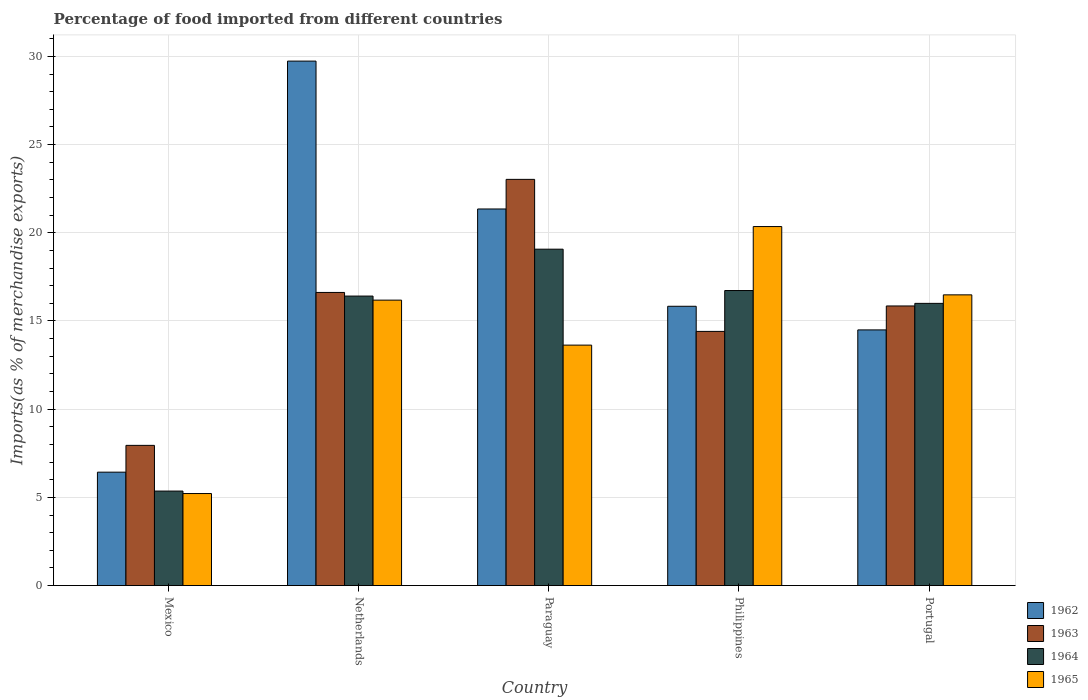Are the number of bars per tick equal to the number of legend labels?
Your answer should be very brief. Yes. Are the number of bars on each tick of the X-axis equal?
Your answer should be very brief. Yes. How many bars are there on the 4th tick from the left?
Your answer should be very brief. 4. What is the label of the 2nd group of bars from the left?
Provide a short and direct response. Netherlands. In how many cases, is the number of bars for a given country not equal to the number of legend labels?
Your answer should be very brief. 0. What is the percentage of imports to different countries in 1964 in Portugal?
Make the answer very short. 16. Across all countries, what is the maximum percentage of imports to different countries in 1965?
Ensure brevity in your answer.  20.35. Across all countries, what is the minimum percentage of imports to different countries in 1962?
Your answer should be compact. 6.43. In which country was the percentage of imports to different countries in 1965 maximum?
Offer a very short reply. Philippines. In which country was the percentage of imports to different countries in 1962 minimum?
Your answer should be compact. Mexico. What is the total percentage of imports to different countries in 1963 in the graph?
Offer a very short reply. 77.86. What is the difference between the percentage of imports to different countries in 1964 in Netherlands and that in Paraguay?
Your response must be concise. -2.66. What is the difference between the percentage of imports to different countries in 1962 in Paraguay and the percentage of imports to different countries in 1965 in Philippines?
Give a very brief answer. 1. What is the average percentage of imports to different countries in 1964 per country?
Your response must be concise. 14.71. What is the difference between the percentage of imports to different countries of/in 1965 and percentage of imports to different countries of/in 1963 in Philippines?
Give a very brief answer. 5.94. In how many countries, is the percentage of imports to different countries in 1963 greater than 10 %?
Provide a short and direct response. 4. What is the ratio of the percentage of imports to different countries in 1962 in Paraguay to that in Portugal?
Give a very brief answer. 1.47. What is the difference between the highest and the second highest percentage of imports to different countries in 1965?
Make the answer very short. 0.3. What is the difference between the highest and the lowest percentage of imports to different countries in 1964?
Give a very brief answer. 13.71. In how many countries, is the percentage of imports to different countries in 1965 greater than the average percentage of imports to different countries in 1965 taken over all countries?
Make the answer very short. 3. Is the sum of the percentage of imports to different countries in 1965 in Netherlands and Portugal greater than the maximum percentage of imports to different countries in 1964 across all countries?
Provide a succinct answer. Yes. What does the 2nd bar from the left in Netherlands represents?
Provide a short and direct response. 1963. How many bars are there?
Keep it short and to the point. 20. What is the difference between two consecutive major ticks on the Y-axis?
Ensure brevity in your answer.  5. How are the legend labels stacked?
Provide a succinct answer. Vertical. What is the title of the graph?
Provide a succinct answer. Percentage of food imported from different countries. Does "1983" appear as one of the legend labels in the graph?
Provide a short and direct response. No. What is the label or title of the X-axis?
Your answer should be very brief. Country. What is the label or title of the Y-axis?
Keep it short and to the point. Imports(as % of merchandise exports). What is the Imports(as % of merchandise exports) in 1962 in Mexico?
Provide a succinct answer. 6.43. What is the Imports(as % of merchandise exports) of 1963 in Mexico?
Your response must be concise. 7.95. What is the Imports(as % of merchandise exports) of 1964 in Mexico?
Make the answer very short. 5.36. What is the Imports(as % of merchandise exports) of 1965 in Mexico?
Provide a short and direct response. 5.22. What is the Imports(as % of merchandise exports) in 1962 in Netherlands?
Keep it short and to the point. 29.73. What is the Imports(as % of merchandise exports) in 1963 in Netherlands?
Make the answer very short. 16.62. What is the Imports(as % of merchandise exports) in 1964 in Netherlands?
Provide a short and direct response. 16.41. What is the Imports(as % of merchandise exports) of 1965 in Netherlands?
Offer a very short reply. 16.18. What is the Imports(as % of merchandise exports) of 1962 in Paraguay?
Make the answer very short. 21.35. What is the Imports(as % of merchandise exports) of 1963 in Paraguay?
Give a very brief answer. 23.03. What is the Imports(as % of merchandise exports) of 1964 in Paraguay?
Your response must be concise. 19.07. What is the Imports(as % of merchandise exports) of 1965 in Paraguay?
Ensure brevity in your answer.  13.63. What is the Imports(as % of merchandise exports) in 1962 in Philippines?
Provide a short and direct response. 15.83. What is the Imports(as % of merchandise exports) of 1963 in Philippines?
Your answer should be compact. 14.41. What is the Imports(as % of merchandise exports) in 1964 in Philippines?
Provide a short and direct response. 16.73. What is the Imports(as % of merchandise exports) in 1965 in Philippines?
Keep it short and to the point. 20.35. What is the Imports(as % of merchandise exports) in 1962 in Portugal?
Ensure brevity in your answer.  14.49. What is the Imports(as % of merchandise exports) of 1963 in Portugal?
Offer a very short reply. 15.85. What is the Imports(as % of merchandise exports) of 1964 in Portugal?
Offer a terse response. 16. What is the Imports(as % of merchandise exports) of 1965 in Portugal?
Your answer should be very brief. 16.48. Across all countries, what is the maximum Imports(as % of merchandise exports) of 1962?
Your answer should be compact. 29.73. Across all countries, what is the maximum Imports(as % of merchandise exports) in 1963?
Give a very brief answer. 23.03. Across all countries, what is the maximum Imports(as % of merchandise exports) of 1964?
Your answer should be compact. 19.07. Across all countries, what is the maximum Imports(as % of merchandise exports) in 1965?
Your answer should be very brief. 20.35. Across all countries, what is the minimum Imports(as % of merchandise exports) in 1962?
Your answer should be compact. 6.43. Across all countries, what is the minimum Imports(as % of merchandise exports) of 1963?
Your response must be concise. 7.95. Across all countries, what is the minimum Imports(as % of merchandise exports) of 1964?
Offer a terse response. 5.36. Across all countries, what is the minimum Imports(as % of merchandise exports) in 1965?
Offer a very short reply. 5.22. What is the total Imports(as % of merchandise exports) in 1962 in the graph?
Make the answer very short. 87.84. What is the total Imports(as % of merchandise exports) in 1963 in the graph?
Your answer should be very brief. 77.86. What is the total Imports(as % of merchandise exports) in 1964 in the graph?
Your answer should be very brief. 73.57. What is the total Imports(as % of merchandise exports) of 1965 in the graph?
Keep it short and to the point. 71.87. What is the difference between the Imports(as % of merchandise exports) of 1962 in Mexico and that in Netherlands?
Keep it short and to the point. -23.31. What is the difference between the Imports(as % of merchandise exports) in 1963 in Mexico and that in Netherlands?
Provide a succinct answer. -8.67. What is the difference between the Imports(as % of merchandise exports) of 1964 in Mexico and that in Netherlands?
Ensure brevity in your answer.  -11.05. What is the difference between the Imports(as % of merchandise exports) of 1965 in Mexico and that in Netherlands?
Your answer should be compact. -10.97. What is the difference between the Imports(as % of merchandise exports) of 1962 in Mexico and that in Paraguay?
Your response must be concise. -14.92. What is the difference between the Imports(as % of merchandise exports) of 1963 in Mexico and that in Paraguay?
Make the answer very short. -15.08. What is the difference between the Imports(as % of merchandise exports) in 1964 in Mexico and that in Paraguay?
Ensure brevity in your answer.  -13.71. What is the difference between the Imports(as % of merchandise exports) in 1965 in Mexico and that in Paraguay?
Offer a very short reply. -8.42. What is the difference between the Imports(as % of merchandise exports) in 1962 in Mexico and that in Philippines?
Your answer should be compact. -9.41. What is the difference between the Imports(as % of merchandise exports) in 1963 in Mexico and that in Philippines?
Your answer should be very brief. -6.46. What is the difference between the Imports(as % of merchandise exports) of 1964 in Mexico and that in Philippines?
Give a very brief answer. -11.37. What is the difference between the Imports(as % of merchandise exports) of 1965 in Mexico and that in Philippines?
Ensure brevity in your answer.  -15.14. What is the difference between the Imports(as % of merchandise exports) of 1962 in Mexico and that in Portugal?
Provide a succinct answer. -8.07. What is the difference between the Imports(as % of merchandise exports) of 1963 in Mexico and that in Portugal?
Your answer should be compact. -7.9. What is the difference between the Imports(as % of merchandise exports) in 1964 in Mexico and that in Portugal?
Provide a short and direct response. -10.64. What is the difference between the Imports(as % of merchandise exports) of 1965 in Mexico and that in Portugal?
Keep it short and to the point. -11.26. What is the difference between the Imports(as % of merchandise exports) of 1962 in Netherlands and that in Paraguay?
Provide a succinct answer. 8.38. What is the difference between the Imports(as % of merchandise exports) of 1963 in Netherlands and that in Paraguay?
Keep it short and to the point. -6.41. What is the difference between the Imports(as % of merchandise exports) in 1964 in Netherlands and that in Paraguay?
Offer a very short reply. -2.66. What is the difference between the Imports(as % of merchandise exports) in 1965 in Netherlands and that in Paraguay?
Offer a terse response. 2.55. What is the difference between the Imports(as % of merchandise exports) in 1962 in Netherlands and that in Philippines?
Provide a short and direct response. 13.9. What is the difference between the Imports(as % of merchandise exports) of 1963 in Netherlands and that in Philippines?
Make the answer very short. 2.21. What is the difference between the Imports(as % of merchandise exports) of 1964 in Netherlands and that in Philippines?
Your answer should be compact. -0.31. What is the difference between the Imports(as % of merchandise exports) of 1965 in Netherlands and that in Philippines?
Your response must be concise. -4.17. What is the difference between the Imports(as % of merchandise exports) in 1962 in Netherlands and that in Portugal?
Your answer should be very brief. 15.24. What is the difference between the Imports(as % of merchandise exports) of 1963 in Netherlands and that in Portugal?
Make the answer very short. 0.77. What is the difference between the Imports(as % of merchandise exports) in 1964 in Netherlands and that in Portugal?
Give a very brief answer. 0.41. What is the difference between the Imports(as % of merchandise exports) of 1965 in Netherlands and that in Portugal?
Your answer should be very brief. -0.3. What is the difference between the Imports(as % of merchandise exports) in 1962 in Paraguay and that in Philippines?
Ensure brevity in your answer.  5.52. What is the difference between the Imports(as % of merchandise exports) in 1963 in Paraguay and that in Philippines?
Provide a short and direct response. 8.62. What is the difference between the Imports(as % of merchandise exports) in 1964 in Paraguay and that in Philippines?
Offer a terse response. 2.35. What is the difference between the Imports(as % of merchandise exports) in 1965 in Paraguay and that in Philippines?
Your answer should be very brief. -6.72. What is the difference between the Imports(as % of merchandise exports) of 1962 in Paraguay and that in Portugal?
Your answer should be very brief. 6.86. What is the difference between the Imports(as % of merchandise exports) of 1963 in Paraguay and that in Portugal?
Make the answer very short. 7.18. What is the difference between the Imports(as % of merchandise exports) in 1964 in Paraguay and that in Portugal?
Ensure brevity in your answer.  3.07. What is the difference between the Imports(as % of merchandise exports) in 1965 in Paraguay and that in Portugal?
Provide a succinct answer. -2.85. What is the difference between the Imports(as % of merchandise exports) in 1962 in Philippines and that in Portugal?
Your answer should be compact. 1.34. What is the difference between the Imports(as % of merchandise exports) of 1963 in Philippines and that in Portugal?
Make the answer very short. -1.44. What is the difference between the Imports(as % of merchandise exports) of 1964 in Philippines and that in Portugal?
Ensure brevity in your answer.  0.73. What is the difference between the Imports(as % of merchandise exports) of 1965 in Philippines and that in Portugal?
Ensure brevity in your answer.  3.87. What is the difference between the Imports(as % of merchandise exports) in 1962 in Mexico and the Imports(as % of merchandise exports) in 1963 in Netherlands?
Provide a short and direct response. -10.19. What is the difference between the Imports(as % of merchandise exports) in 1962 in Mexico and the Imports(as % of merchandise exports) in 1964 in Netherlands?
Provide a succinct answer. -9.98. What is the difference between the Imports(as % of merchandise exports) of 1962 in Mexico and the Imports(as % of merchandise exports) of 1965 in Netherlands?
Keep it short and to the point. -9.75. What is the difference between the Imports(as % of merchandise exports) in 1963 in Mexico and the Imports(as % of merchandise exports) in 1964 in Netherlands?
Your answer should be very brief. -8.46. What is the difference between the Imports(as % of merchandise exports) in 1963 in Mexico and the Imports(as % of merchandise exports) in 1965 in Netherlands?
Give a very brief answer. -8.23. What is the difference between the Imports(as % of merchandise exports) of 1964 in Mexico and the Imports(as % of merchandise exports) of 1965 in Netherlands?
Offer a very short reply. -10.83. What is the difference between the Imports(as % of merchandise exports) of 1962 in Mexico and the Imports(as % of merchandise exports) of 1963 in Paraguay?
Offer a very short reply. -16.6. What is the difference between the Imports(as % of merchandise exports) in 1962 in Mexico and the Imports(as % of merchandise exports) in 1964 in Paraguay?
Your response must be concise. -12.64. What is the difference between the Imports(as % of merchandise exports) of 1962 in Mexico and the Imports(as % of merchandise exports) of 1965 in Paraguay?
Your response must be concise. -7.2. What is the difference between the Imports(as % of merchandise exports) of 1963 in Mexico and the Imports(as % of merchandise exports) of 1964 in Paraguay?
Offer a very short reply. -11.12. What is the difference between the Imports(as % of merchandise exports) of 1963 in Mexico and the Imports(as % of merchandise exports) of 1965 in Paraguay?
Provide a short and direct response. -5.68. What is the difference between the Imports(as % of merchandise exports) in 1964 in Mexico and the Imports(as % of merchandise exports) in 1965 in Paraguay?
Make the answer very short. -8.27. What is the difference between the Imports(as % of merchandise exports) in 1962 in Mexico and the Imports(as % of merchandise exports) in 1963 in Philippines?
Ensure brevity in your answer.  -7.98. What is the difference between the Imports(as % of merchandise exports) of 1962 in Mexico and the Imports(as % of merchandise exports) of 1964 in Philippines?
Your answer should be very brief. -10.3. What is the difference between the Imports(as % of merchandise exports) of 1962 in Mexico and the Imports(as % of merchandise exports) of 1965 in Philippines?
Make the answer very short. -13.93. What is the difference between the Imports(as % of merchandise exports) in 1963 in Mexico and the Imports(as % of merchandise exports) in 1964 in Philippines?
Your response must be concise. -8.78. What is the difference between the Imports(as % of merchandise exports) of 1963 in Mexico and the Imports(as % of merchandise exports) of 1965 in Philippines?
Your answer should be compact. -12.41. What is the difference between the Imports(as % of merchandise exports) in 1964 in Mexico and the Imports(as % of merchandise exports) in 1965 in Philippines?
Ensure brevity in your answer.  -15. What is the difference between the Imports(as % of merchandise exports) of 1962 in Mexico and the Imports(as % of merchandise exports) of 1963 in Portugal?
Your response must be concise. -9.42. What is the difference between the Imports(as % of merchandise exports) of 1962 in Mexico and the Imports(as % of merchandise exports) of 1964 in Portugal?
Provide a short and direct response. -9.57. What is the difference between the Imports(as % of merchandise exports) in 1962 in Mexico and the Imports(as % of merchandise exports) in 1965 in Portugal?
Ensure brevity in your answer.  -10.05. What is the difference between the Imports(as % of merchandise exports) of 1963 in Mexico and the Imports(as % of merchandise exports) of 1964 in Portugal?
Make the answer very short. -8.05. What is the difference between the Imports(as % of merchandise exports) of 1963 in Mexico and the Imports(as % of merchandise exports) of 1965 in Portugal?
Give a very brief answer. -8.53. What is the difference between the Imports(as % of merchandise exports) of 1964 in Mexico and the Imports(as % of merchandise exports) of 1965 in Portugal?
Give a very brief answer. -11.12. What is the difference between the Imports(as % of merchandise exports) in 1962 in Netherlands and the Imports(as % of merchandise exports) in 1963 in Paraguay?
Offer a very short reply. 6.71. What is the difference between the Imports(as % of merchandise exports) in 1962 in Netherlands and the Imports(as % of merchandise exports) in 1964 in Paraguay?
Keep it short and to the point. 10.66. What is the difference between the Imports(as % of merchandise exports) in 1962 in Netherlands and the Imports(as % of merchandise exports) in 1965 in Paraguay?
Offer a terse response. 16.1. What is the difference between the Imports(as % of merchandise exports) in 1963 in Netherlands and the Imports(as % of merchandise exports) in 1964 in Paraguay?
Provide a short and direct response. -2.45. What is the difference between the Imports(as % of merchandise exports) in 1963 in Netherlands and the Imports(as % of merchandise exports) in 1965 in Paraguay?
Your answer should be compact. 2.99. What is the difference between the Imports(as % of merchandise exports) of 1964 in Netherlands and the Imports(as % of merchandise exports) of 1965 in Paraguay?
Offer a very short reply. 2.78. What is the difference between the Imports(as % of merchandise exports) in 1962 in Netherlands and the Imports(as % of merchandise exports) in 1963 in Philippines?
Provide a succinct answer. 15.32. What is the difference between the Imports(as % of merchandise exports) in 1962 in Netherlands and the Imports(as % of merchandise exports) in 1964 in Philippines?
Your answer should be very brief. 13.01. What is the difference between the Imports(as % of merchandise exports) of 1962 in Netherlands and the Imports(as % of merchandise exports) of 1965 in Philippines?
Offer a terse response. 9.38. What is the difference between the Imports(as % of merchandise exports) in 1963 in Netherlands and the Imports(as % of merchandise exports) in 1964 in Philippines?
Provide a short and direct response. -0.11. What is the difference between the Imports(as % of merchandise exports) of 1963 in Netherlands and the Imports(as % of merchandise exports) of 1965 in Philippines?
Provide a succinct answer. -3.74. What is the difference between the Imports(as % of merchandise exports) of 1964 in Netherlands and the Imports(as % of merchandise exports) of 1965 in Philippines?
Provide a short and direct response. -3.94. What is the difference between the Imports(as % of merchandise exports) in 1962 in Netherlands and the Imports(as % of merchandise exports) in 1963 in Portugal?
Ensure brevity in your answer.  13.88. What is the difference between the Imports(as % of merchandise exports) in 1962 in Netherlands and the Imports(as % of merchandise exports) in 1964 in Portugal?
Provide a short and direct response. 13.74. What is the difference between the Imports(as % of merchandise exports) of 1962 in Netherlands and the Imports(as % of merchandise exports) of 1965 in Portugal?
Offer a terse response. 13.25. What is the difference between the Imports(as % of merchandise exports) of 1963 in Netherlands and the Imports(as % of merchandise exports) of 1964 in Portugal?
Your response must be concise. 0.62. What is the difference between the Imports(as % of merchandise exports) in 1963 in Netherlands and the Imports(as % of merchandise exports) in 1965 in Portugal?
Offer a terse response. 0.14. What is the difference between the Imports(as % of merchandise exports) of 1964 in Netherlands and the Imports(as % of merchandise exports) of 1965 in Portugal?
Make the answer very short. -0.07. What is the difference between the Imports(as % of merchandise exports) in 1962 in Paraguay and the Imports(as % of merchandise exports) in 1963 in Philippines?
Your answer should be compact. 6.94. What is the difference between the Imports(as % of merchandise exports) of 1962 in Paraguay and the Imports(as % of merchandise exports) of 1964 in Philippines?
Offer a very short reply. 4.62. What is the difference between the Imports(as % of merchandise exports) of 1962 in Paraguay and the Imports(as % of merchandise exports) of 1965 in Philippines?
Provide a succinct answer. 1. What is the difference between the Imports(as % of merchandise exports) in 1963 in Paraguay and the Imports(as % of merchandise exports) in 1964 in Philippines?
Ensure brevity in your answer.  6.3. What is the difference between the Imports(as % of merchandise exports) in 1963 in Paraguay and the Imports(as % of merchandise exports) in 1965 in Philippines?
Keep it short and to the point. 2.67. What is the difference between the Imports(as % of merchandise exports) of 1964 in Paraguay and the Imports(as % of merchandise exports) of 1965 in Philippines?
Keep it short and to the point. -1.28. What is the difference between the Imports(as % of merchandise exports) of 1962 in Paraguay and the Imports(as % of merchandise exports) of 1963 in Portugal?
Make the answer very short. 5.5. What is the difference between the Imports(as % of merchandise exports) in 1962 in Paraguay and the Imports(as % of merchandise exports) in 1964 in Portugal?
Offer a terse response. 5.35. What is the difference between the Imports(as % of merchandise exports) of 1962 in Paraguay and the Imports(as % of merchandise exports) of 1965 in Portugal?
Provide a short and direct response. 4.87. What is the difference between the Imports(as % of merchandise exports) in 1963 in Paraguay and the Imports(as % of merchandise exports) in 1964 in Portugal?
Offer a terse response. 7.03. What is the difference between the Imports(as % of merchandise exports) in 1963 in Paraguay and the Imports(as % of merchandise exports) in 1965 in Portugal?
Provide a short and direct response. 6.55. What is the difference between the Imports(as % of merchandise exports) in 1964 in Paraguay and the Imports(as % of merchandise exports) in 1965 in Portugal?
Keep it short and to the point. 2.59. What is the difference between the Imports(as % of merchandise exports) in 1962 in Philippines and the Imports(as % of merchandise exports) in 1963 in Portugal?
Keep it short and to the point. -0.02. What is the difference between the Imports(as % of merchandise exports) of 1962 in Philippines and the Imports(as % of merchandise exports) of 1964 in Portugal?
Keep it short and to the point. -0.16. What is the difference between the Imports(as % of merchandise exports) of 1962 in Philippines and the Imports(as % of merchandise exports) of 1965 in Portugal?
Keep it short and to the point. -0.65. What is the difference between the Imports(as % of merchandise exports) in 1963 in Philippines and the Imports(as % of merchandise exports) in 1964 in Portugal?
Make the answer very short. -1.59. What is the difference between the Imports(as % of merchandise exports) of 1963 in Philippines and the Imports(as % of merchandise exports) of 1965 in Portugal?
Provide a short and direct response. -2.07. What is the difference between the Imports(as % of merchandise exports) of 1964 in Philippines and the Imports(as % of merchandise exports) of 1965 in Portugal?
Provide a short and direct response. 0.24. What is the average Imports(as % of merchandise exports) in 1962 per country?
Provide a short and direct response. 17.57. What is the average Imports(as % of merchandise exports) in 1963 per country?
Provide a short and direct response. 15.57. What is the average Imports(as % of merchandise exports) of 1964 per country?
Give a very brief answer. 14.71. What is the average Imports(as % of merchandise exports) of 1965 per country?
Your response must be concise. 14.37. What is the difference between the Imports(as % of merchandise exports) of 1962 and Imports(as % of merchandise exports) of 1963 in Mexico?
Make the answer very short. -1.52. What is the difference between the Imports(as % of merchandise exports) in 1962 and Imports(as % of merchandise exports) in 1964 in Mexico?
Offer a very short reply. 1.07. What is the difference between the Imports(as % of merchandise exports) of 1962 and Imports(as % of merchandise exports) of 1965 in Mexico?
Offer a terse response. 1.21. What is the difference between the Imports(as % of merchandise exports) of 1963 and Imports(as % of merchandise exports) of 1964 in Mexico?
Give a very brief answer. 2.59. What is the difference between the Imports(as % of merchandise exports) of 1963 and Imports(as % of merchandise exports) of 1965 in Mexico?
Offer a very short reply. 2.73. What is the difference between the Imports(as % of merchandise exports) in 1964 and Imports(as % of merchandise exports) in 1965 in Mexico?
Provide a succinct answer. 0.14. What is the difference between the Imports(as % of merchandise exports) in 1962 and Imports(as % of merchandise exports) in 1963 in Netherlands?
Provide a short and direct response. 13.12. What is the difference between the Imports(as % of merchandise exports) of 1962 and Imports(as % of merchandise exports) of 1964 in Netherlands?
Ensure brevity in your answer.  13.32. What is the difference between the Imports(as % of merchandise exports) in 1962 and Imports(as % of merchandise exports) in 1965 in Netherlands?
Provide a short and direct response. 13.55. What is the difference between the Imports(as % of merchandise exports) of 1963 and Imports(as % of merchandise exports) of 1964 in Netherlands?
Your response must be concise. 0.21. What is the difference between the Imports(as % of merchandise exports) of 1963 and Imports(as % of merchandise exports) of 1965 in Netherlands?
Your answer should be compact. 0.44. What is the difference between the Imports(as % of merchandise exports) of 1964 and Imports(as % of merchandise exports) of 1965 in Netherlands?
Your answer should be very brief. 0.23. What is the difference between the Imports(as % of merchandise exports) in 1962 and Imports(as % of merchandise exports) in 1963 in Paraguay?
Your response must be concise. -1.68. What is the difference between the Imports(as % of merchandise exports) of 1962 and Imports(as % of merchandise exports) of 1964 in Paraguay?
Keep it short and to the point. 2.28. What is the difference between the Imports(as % of merchandise exports) in 1962 and Imports(as % of merchandise exports) in 1965 in Paraguay?
Provide a short and direct response. 7.72. What is the difference between the Imports(as % of merchandise exports) of 1963 and Imports(as % of merchandise exports) of 1964 in Paraguay?
Provide a short and direct response. 3.96. What is the difference between the Imports(as % of merchandise exports) of 1963 and Imports(as % of merchandise exports) of 1965 in Paraguay?
Make the answer very short. 9.4. What is the difference between the Imports(as % of merchandise exports) of 1964 and Imports(as % of merchandise exports) of 1965 in Paraguay?
Make the answer very short. 5.44. What is the difference between the Imports(as % of merchandise exports) in 1962 and Imports(as % of merchandise exports) in 1963 in Philippines?
Give a very brief answer. 1.43. What is the difference between the Imports(as % of merchandise exports) of 1962 and Imports(as % of merchandise exports) of 1964 in Philippines?
Offer a very short reply. -0.89. What is the difference between the Imports(as % of merchandise exports) in 1962 and Imports(as % of merchandise exports) in 1965 in Philippines?
Ensure brevity in your answer.  -4.52. What is the difference between the Imports(as % of merchandise exports) of 1963 and Imports(as % of merchandise exports) of 1964 in Philippines?
Offer a terse response. -2.32. What is the difference between the Imports(as % of merchandise exports) of 1963 and Imports(as % of merchandise exports) of 1965 in Philippines?
Your answer should be compact. -5.94. What is the difference between the Imports(as % of merchandise exports) in 1964 and Imports(as % of merchandise exports) in 1965 in Philippines?
Ensure brevity in your answer.  -3.63. What is the difference between the Imports(as % of merchandise exports) in 1962 and Imports(as % of merchandise exports) in 1963 in Portugal?
Keep it short and to the point. -1.36. What is the difference between the Imports(as % of merchandise exports) in 1962 and Imports(as % of merchandise exports) in 1964 in Portugal?
Provide a succinct answer. -1.5. What is the difference between the Imports(as % of merchandise exports) in 1962 and Imports(as % of merchandise exports) in 1965 in Portugal?
Your response must be concise. -1.99. What is the difference between the Imports(as % of merchandise exports) of 1963 and Imports(as % of merchandise exports) of 1964 in Portugal?
Keep it short and to the point. -0.15. What is the difference between the Imports(as % of merchandise exports) in 1963 and Imports(as % of merchandise exports) in 1965 in Portugal?
Your response must be concise. -0.63. What is the difference between the Imports(as % of merchandise exports) in 1964 and Imports(as % of merchandise exports) in 1965 in Portugal?
Keep it short and to the point. -0.48. What is the ratio of the Imports(as % of merchandise exports) in 1962 in Mexico to that in Netherlands?
Ensure brevity in your answer.  0.22. What is the ratio of the Imports(as % of merchandise exports) of 1963 in Mexico to that in Netherlands?
Your answer should be very brief. 0.48. What is the ratio of the Imports(as % of merchandise exports) of 1964 in Mexico to that in Netherlands?
Make the answer very short. 0.33. What is the ratio of the Imports(as % of merchandise exports) in 1965 in Mexico to that in Netherlands?
Keep it short and to the point. 0.32. What is the ratio of the Imports(as % of merchandise exports) in 1962 in Mexico to that in Paraguay?
Make the answer very short. 0.3. What is the ratio of the Imports(as % of merchandise exports) of 1963 in Mexico to that in Paraguay?
Your response must be concise. 0.35. What is the ratio of the Imports(as % of merchandise exports) of 1964 in Mexico to that in Paraguay?
Provide a succinct answer. 0.28. What is the ratio of the Imports(as % of merchandise exports) of 1965 in Mexico to that in Paraguay?
Your answer should be compact. 0.38. What is the ratio of the Imports(as % of merchandise exports) of 1962 in Mexico to that in Philippines?
Keep it short and to the point. 0.41. What is the ratio of the Imports(as % of merchandise exports) of 1963 in Mexico to that in Philippines?
Your answer should be compact. 0.55. What is the ratio of the Imports(as % of merchandise exports) in 1964 in Mexico to that in Philippines?
Provide a succinct answer. 0.32. What is the ratio of the Imports(as % of merchandise exports) in 1965 in Mexico to that in Philippines?
Make the answer very short. 0.26. What is the ratio of the Imports(as % of merchandise exports) of 1962 in Mexico to that in Portugal?
Your response must be concise. 0.44. What is the ratio of the Imports(as % of merchandise exports) in 1963 in Mexico to that in Portugal?
Provide a short and direct response. 0.5. What is the ratio of the Imports(as % of merchandise exports) of 1964 in Mexico to that in Portugal?
Make the answer very short. 0.33. What is the ratio of the Imports(as % of merchandise exports) in 1965 in Mexico to that in Portugal?
Give a very brief answer. 0.32. What is the ratio of the Imports(as % of merchandise exports) of 1962 in Netherlands to that in Paraguay?
Ensure brevity in your answer.  1.39. What is the ratio of the Imports(as % of merchandise exports) of 1963 in Netherlands to that in Paraguay?
Keep it short and to the point. 0.72. What is the ratio of the Imports(as % of merchandise exports) in 1964 in Netherlands to that in Paraguay?
Provide a short and direct response. 0.86. What is the ratio of the Imports(as % of merchandise exports) in 1965 in Netherlands to that in Paraguay?
Keep it short and to the point. 1.19. What is the ratio of the Imports(as % of merchandise exports) of 1962 in Netherlands to that in Philippines?
Your answer should be very brief. 1.88. What is the ratio of the Imports(as % of merchandise exports) of 1963 in Netherlands to that in Philippines?
Ensure brevity in your answer.  1.15. What is the ratio of the Imports(as % of merchandise exports) of 1964 in Netherlands to that in Philippines?
Ensure brevity in your answer.  0.98. What is the ratio of the Imports(as % of merchandise exports) of 1965 in Netherlands to that in Philippines?
Provide a succinct answer. 0.8. What is the ratio of the Imports(as % of merchandise exports) in 1962 in Netherlands to that in Portugal?
Give a very brief answer. 2.05. What is the ratio of the Imports(as % of merchandise exports) of 1963 in Netherlands to that in Portugal?
Your response must be concise. 1.05. What is the ratio of the Imports(as % of merchandise exports) in 1964 in Netherlands to that in Portugal?
Offer a very short reply. 1.03. What is the ratio of the Imports(as % of merchandise exports) of 1965 in Netherlands to that in Portugal?
Your answer should be very brief. 0.98. What is the ratio of the Imports(as % of merchandise exports) in 1962 in Paraguay to that in Philippines?
Give a very brief answer. 1.35. What is the ratio of the Imports(as % of merchandise exports) of 1963 in Paraguay to that in Philippines?
Provide a succinct answer. 1.6. What is the ratio of the Imports(as % of merchandise exports) in 1964 in Paraguay to that in Philippines?
Your answer should be compact. 1.14. What is the ratio of the Imports(as % of merchandise exports) of 1965 in Paraguay to that in Philippines?
Offer a very short reply. 0.67. What is the ratio of the Imports(as % of merchandise exports) in 1962 in Paraguay to that in Portugal?
Your response must be concise. 1.47. What is the ratio of the Imports(as % of merchandise exports) in 1963 in Paraguay to that in Portugal?
Your response must be concise. 1.45. What is the ratio of the Imports(as % of merchandise exports) of 1964 in Paraguay to that in Portugal?
Provide a succinct answer. 1.19. What is the ratio of the Imports(as % of merchandise exports) in 1965 in Paraguay to that in Portugal?
Offer a very short reply. 0.83. What is the ratio of the Imports(as % of merchandise exports) in 1962 in Philippines to that in Portugal?
Your response must be concise. 1.09. What is the ratio of the Imports(as % of merchandise exports) of 1963 in Philippines to that in Portugal?
Make the answer very short. 0.91. What is the ratio of the Imports(as % of merchandise exports) of 1964 in Philippines to that in Portugal?
Offer a terse response. 1.05. What is the ratio of the Imports(as % of merchandise exports) of 1965 in Philippines to that in Portugal?
Provide a short and direct response. 1.24. What is the difference between the highest and the second highest Imports(as % of merchandise exports) of 1962?
Offer a terse response. 8.38. What is the difference between the highest and the second highest Imports(as % of merchandise exports) of 1963?
Provide a succinct answer. 6.41. What is the difference between the highest and the second highest Imports(as % of merchandise exports) of 1964?
Make the answer very short. 2.35. What is the difference between the highest and the second highest Imports(as % of merchandise exports) in 1965?
Make the answer very short. 3.87. What is the difference between the highest and the lowest Imports(as % of merchandise exports) of 1962?
Keep it short and to the point. 23.31. What is the difference between the highest and the lowest Imports(as % of merchandise exports) of 1963?
Keep it short and to the point. 15.08. What is the difference between the highest and the lowest Imports(as % of merchandise exports) of 1964?
Your answer should be very brief. 13.71. What is the difference between the highest and the lowest Imports(as % of merchandise exports) of 1965?
Make the answer very short. 15.14. 